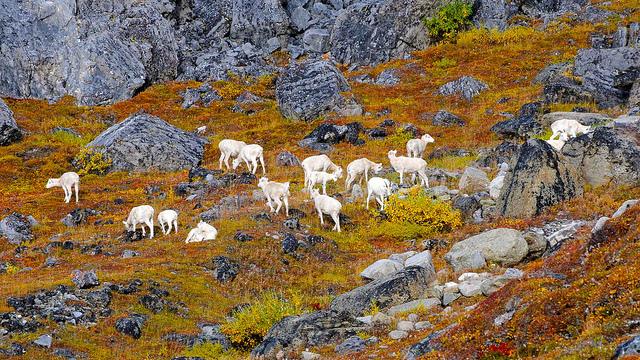What time of year is it likely to be?
Quick response, please. Fall. How many animals are laying down?
Be succinct. 1. Can you count the number of goats easily?
Keep it brief. Yes. Are the animals swimming?
Write a very short answer. No. Is the terrain rocky?
Answer briefly. Yes. 